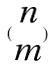<formula> <loc_0><loc_0><loc_500><loc_500>( \begin{matrix} n \\ m \end{matrix} )</formula> 